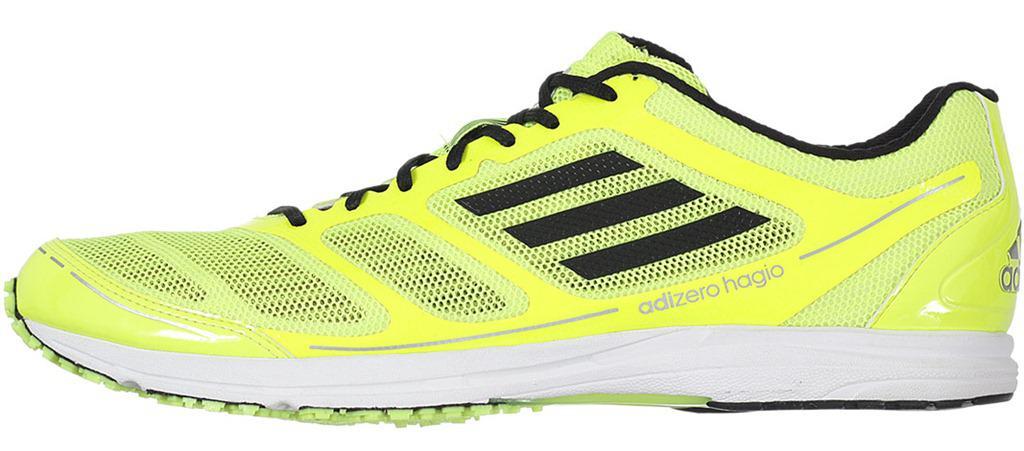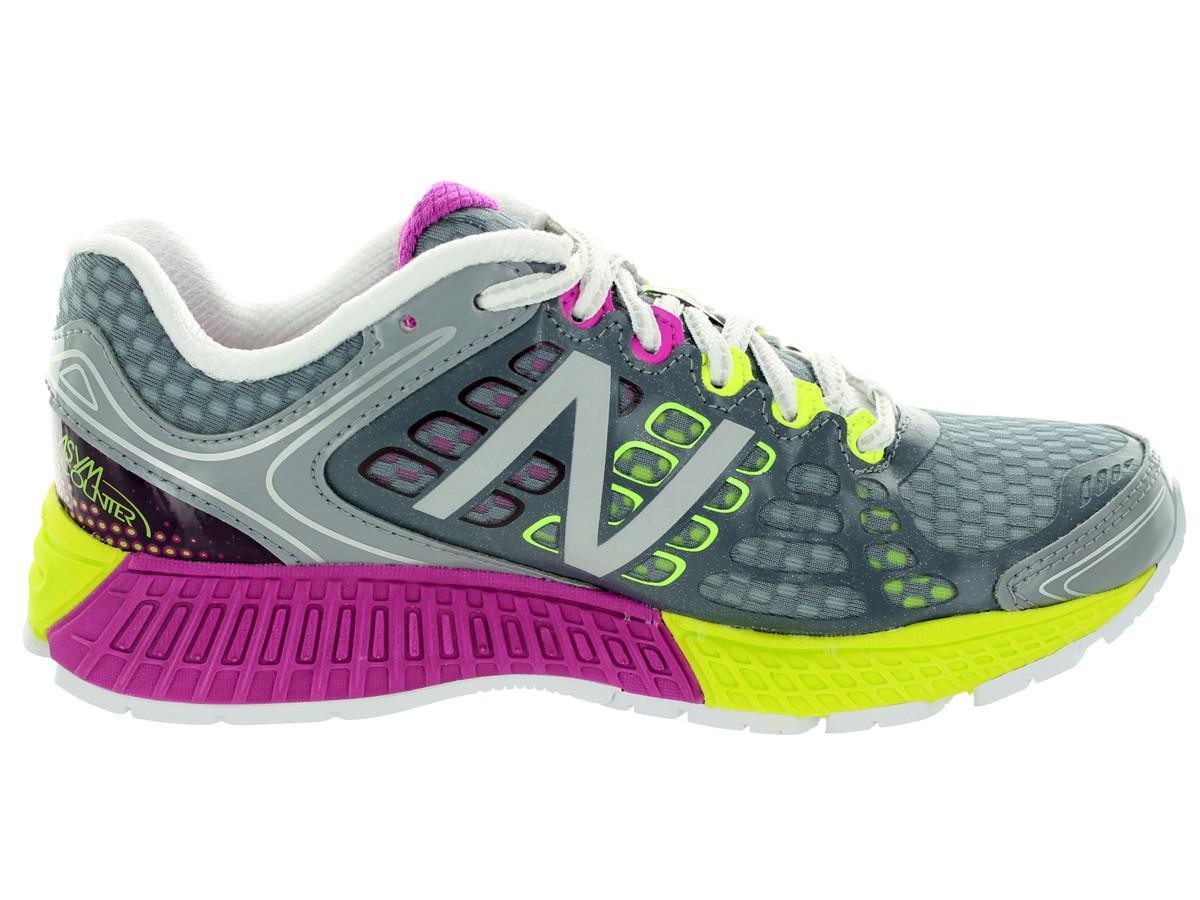The first image is the image on the left, the second image is the image on the right. Analyze the images presented: Is the assertion "The left image contains a sports show who's toe is facing towards the right." valid? Answer yes or no. No. The first image is the image on the left, the second image is the image on the right. For the images shown, is this caption "Each image shows a single sneaker, and right and left images are posed heel to heel." true? Answer yes or no. Yes. 